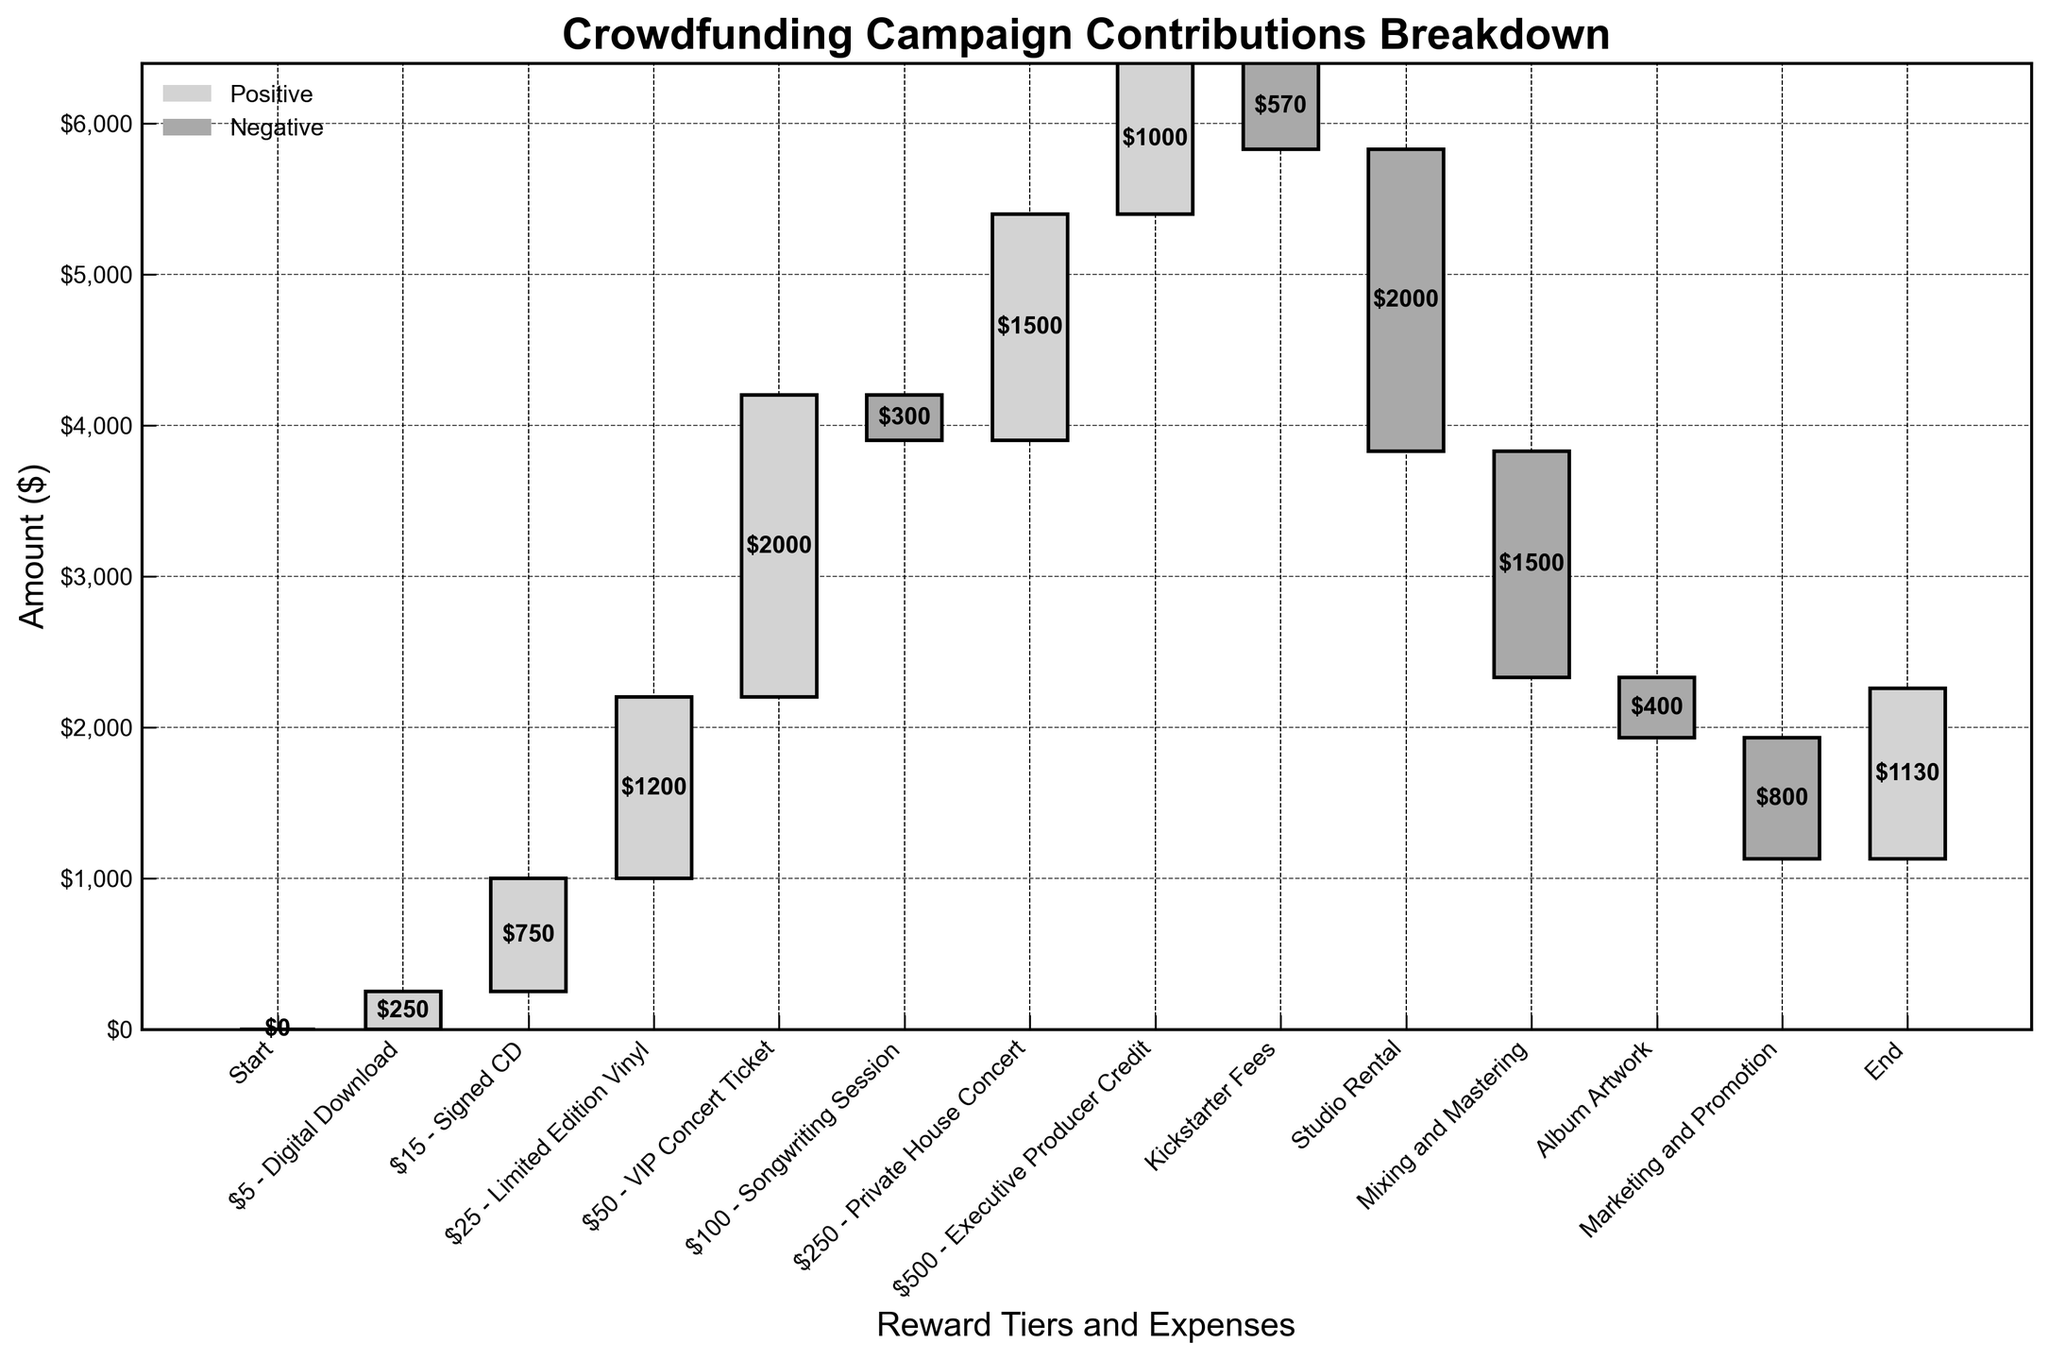How much money is generated from the VIP Concert Ticket tier? The VIP Concert Ticket tier contributes $2000 according to the value at its corresponding bar in the chart.
Answer: $2000 What's the final amount remaining after all contributions and expenses? The final amount is represented by the last category labeled "End" and its value is $1130.
Answer: $1130 Which reward tier generated the highest contribution? The highest contribution is from the VIP Concert Ticket tier, with a value of $2000.
Answer: VIP Concert Ticket How much money is spent on Studio Rental and Mixing and Mastering combined? Adding the expenses: Studio Rental is $2000 and Mixing and Mastering is $1500, so the total is $2000 + $1500 = $3500.
Answer: $3500 What is the net gain or loss from the Songwriting Session tier? The Songwriting Session tier has a negative value of -$300, indicating a loss.
Answer: -$300 How do the total contributions for Limited Edition Vinyl and Executive Producer Credit compare? Adding the contributions: Limited Edition Vinyl is $1200 and Executive Producer Credit is $1000. Limited Edition Vinyl generates more, with a difference of $1200 - $1000 = $200.
Answer: $200 more Which expense has the highest value? Studio Rental has the highest expense with a value of $2000.
Answer: Studio Rental What's the overall gain from all the reward tiers before expenses? Summing up the contributions: $5 Digital Download ($250), $15 Signed CD ($750), $25 Limited Edition Vinyl ($1200), $50 VIP Concert Ticket ($2000), $100 Songwriting Session (-$300), $250 Private House Concert ($1500), $500 Executive Producer Credit ($1000). Total gain is $250 + $750 + $1200 + $2000 - $300 + $1500 + $1000 = $6400.
Answer: $6400 What is the impact of Kickstarter Fees on the total funds raised? The Kickstarter Fees are -$570, representing a deduction from the total funds.
Answer: -$570 Which is the highest expense after Studio Rental? The highest expense after Studio Rental is Mixing and Mastering with a value of $1500.
Answer: Mixing and Mastering 